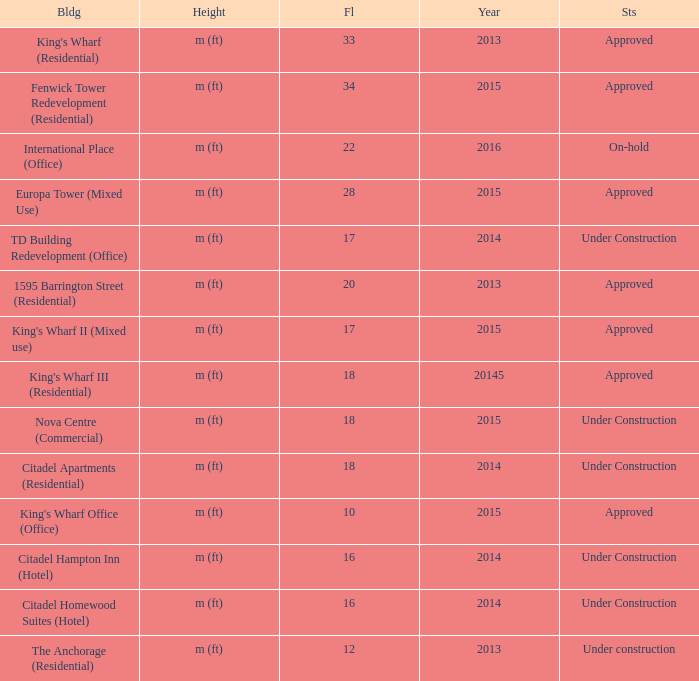What is the status of the building for 2014 with 33 floors? Approved. 